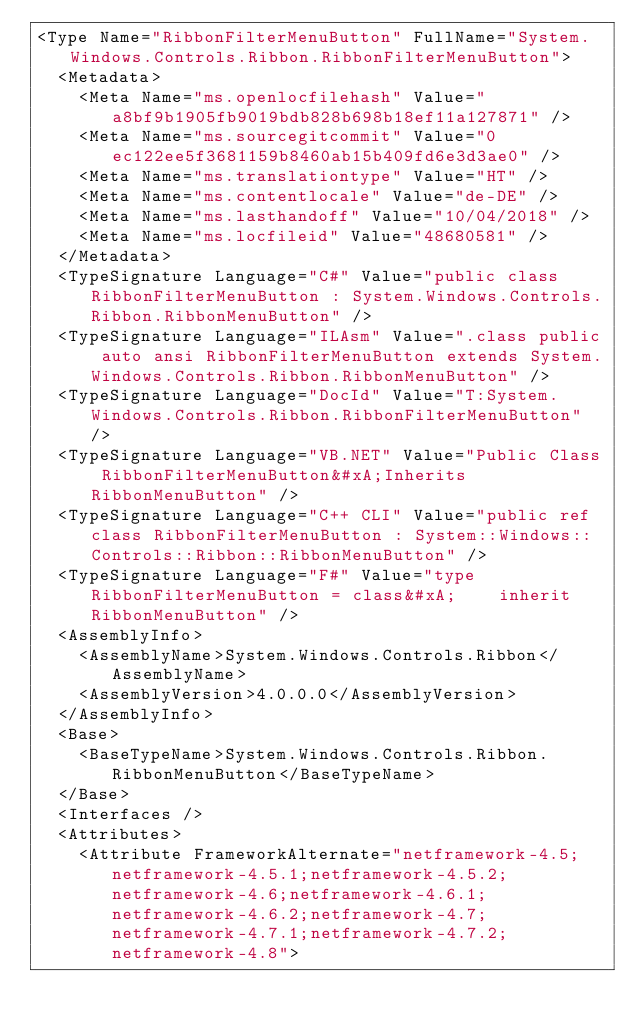<code> <loc_0><loc_0><loc_500><loc_500><_XML_><Type Name="RibbonFilterMenuButton" FullName="System.Windows.Controls.Ribbon.RibbonFilterMenuButton">
  <Metadata>
    <Meta Name="ms.openlocfilehash" Value="a8bf9b1905fb9019bdb828b698b18ef11a127871" />
    <Meta Name="ms.sourcegitcommit" Value="0ec122ee5f3681159b8460ab15b409fd6e3d3ae0" />
    <Meta Name="ms.translationtype" Value="HT" />
    <Meta Name="ms.contentlocale" Value="de-DE" />
    <Meta Name="ms.lasthandoff" Value="10/04/2018" />
    <Meta Name="ms.locfileid" Value="48680581" />
  </Metadata>
  <TypeSignature Language="C#" Value="public class RibbonFilterMenuButton : System.Windows.Controls.Ribbon.RibbonMenuButton" />
  <TypeSignature Language="ILAsm" Value=".class public auto ansi RibbonFilterMenuButton extends System.Windows.Controls.Ribbon.RibbonMenuButton" />
  <TypeSignature Language="DocId" Value="T:System.Windows.Controls.Ribbon.RibbonFilterMenuButton" />
  <TypeSignature Language="VB.NET" Value="Public Class RibbonFilterMenuButton&#xA;Inherits RibbonMenuButton" />
  <TypeSignature Language="C++ CLI" Value="public ref class RibbonFilterMenuButton : System::Windows::Controls::Ribbon::RibbonMenuButton" />
  <TypeSignature Language="F#" Value="type RibbonFilterMenuButton = class&#xA;    inherit RibbonMenuButton" />
  <AssemblyInfo>
    <AssemblyName>System.Windows.Controls.Ribbon</AssemblyName>
    <AssemblyVersion>4.0.0.0</AssemblyVersion>
  </AssemblyInfo>
  <Base>
    <BaseTypeName>System.Windows.Controls.Ribbon.RibbonMenuButton</BaseTypeName>
  </Base>
  <Interfaces />
  <Attributes>
    <Attribute FrameworkAlternate="netframework-4.5;netframework-4.5.1;netframework-4.5.2;netframework-4.6;netframework-4.6.1;netframework-4.6.2;netframework-4.7;netframework-4.7.1;netframework-4.7.2;netframework-4.8"></code> 